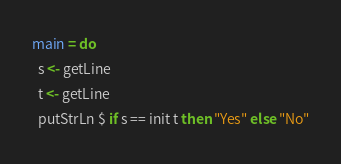<code> <loc_0><loc_0><loc_500><loc_500><_Haskell_>main = do
  s <- getLine
  t <- getLine
  putStrLn $ if s == init t then "Yes" else "No"</code> 